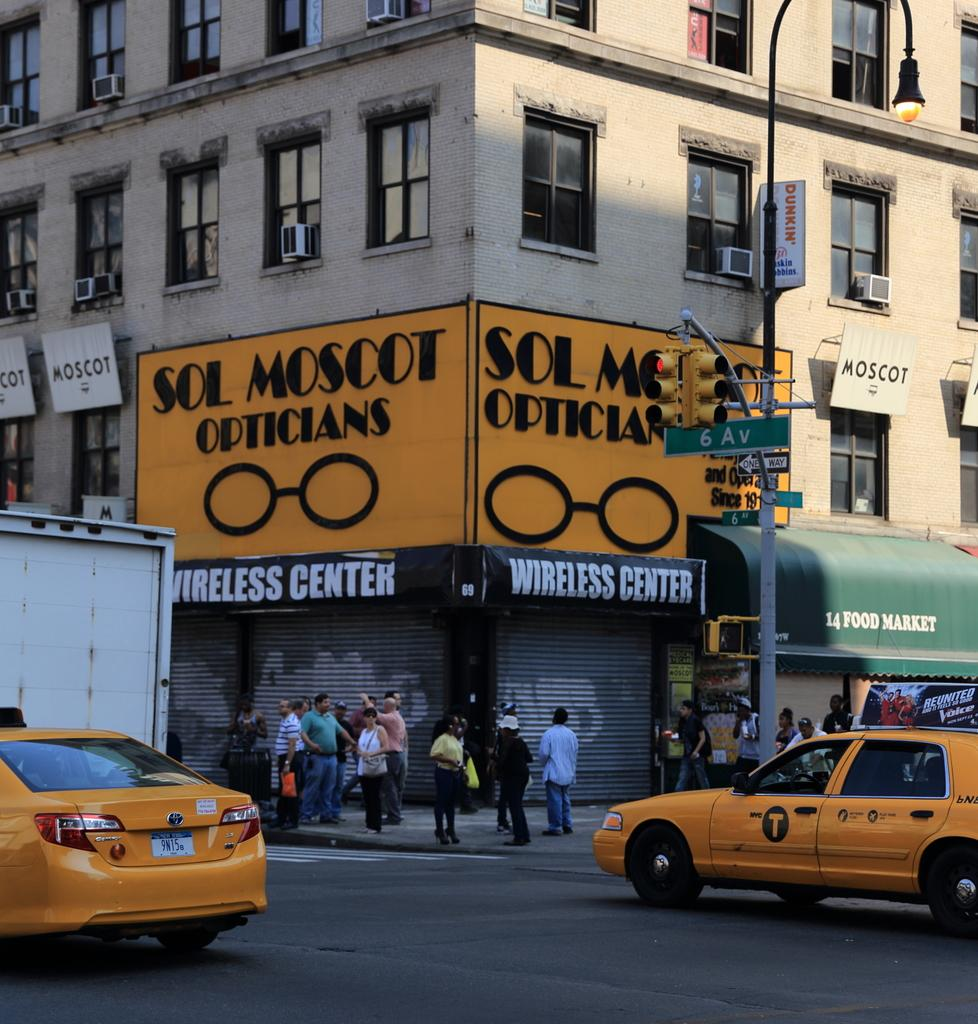<image>
Provide a brief description of the given image. A street corner with a Sol Moscot on the building. 